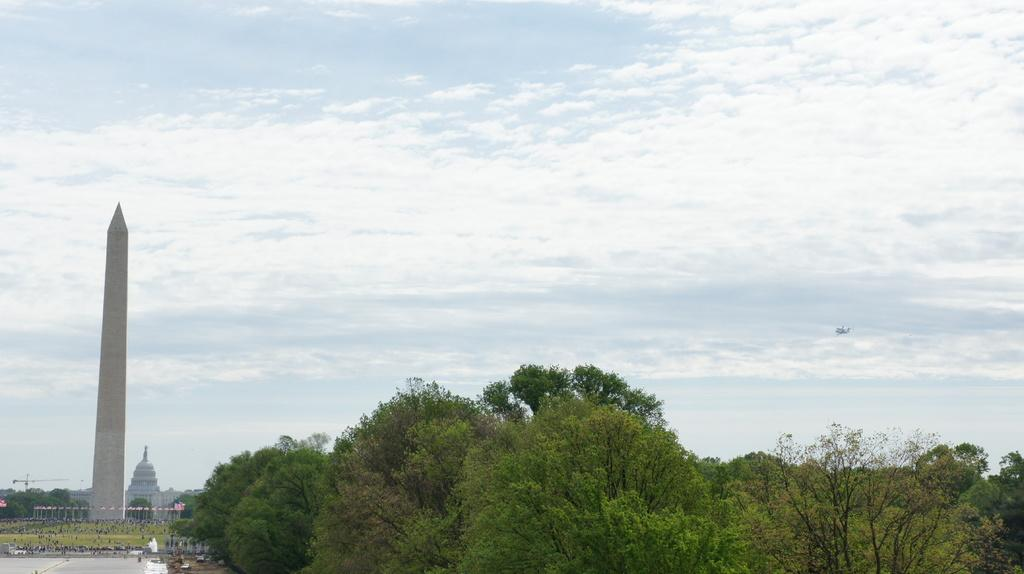What type of vegetation can be seen in the image? There are trees in the image. What type of structures are present in the image? There are buildings in the image. What can be seen in the sky in the image? There are clouds in the image. What is visible in the background of the image? The sky is visible in the image. What color is the ground in the image? The ground in the image is green. What type of rifle is being used to mine zinc in the image? There is no rifle or zinc mining activity present in the image. The image features trees, buildings, clouds, sky, and green ground. 